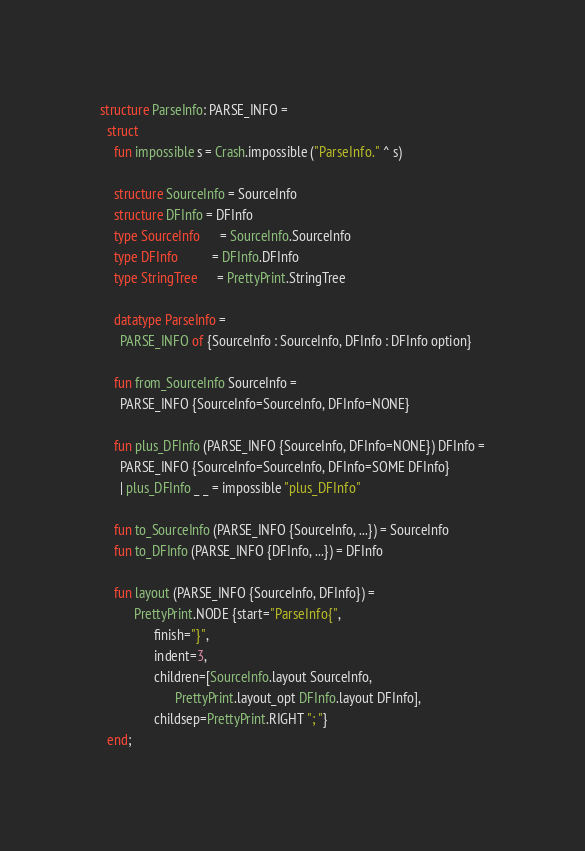<code> <loc_0><loc_0><loc_500><loc_500><_SML_>structure ParseInfo: PARSE_INFO =
  struct
    fun impossible s = Crash.impossible ("ParseInfo." ^ s)

    structure SourceInfo = SourceInfo
    structure DFInfo = DFInfo
    type SourceInfo      = SourceInfo.SourceInfo
    type DFInfo          = DFInfo.DFInfo
    type StringTree      = PrettyPrint.StringTree

    datatype ParseInfo =
      PARSE_INFO of {SourceInfo : SourceInfo, DFInfo : DFInfo option}

    fun from_SourceInfo SourceInfo =
	  PARSE_INFO {SourceInfo=SourceInfo, DFInfo=NONE}

    fun plus_DFInfo (PARSE_INFO {SourceInfo, DFInfo=NONE}) DFInfo =
	  PARSE_INFO {SourceInfo=SourceInfo, DFInfo=SOME DFInfo}
      | plus_DFInfo _ _ = impossible "plus_DFInfo"

    fun to_SourceInfo (PARSE_INFO {SourceInfo, ...}) = SourceInfo
    fun to_DFInfo (PARSE_INFO {DFInfo, ...}) = DFInfo

    fun layout (PARSE_INFO {SourceInfo, DFInfo}) =
          PrettyPrint.NODE {start="ParseInfo{",
			    finish="}",
			    indent=3,
			    children=[SourceInfo.layout SourceInfo,
				      PrettyPrint.layout_opt DFInfo.layout DFInfo],
			    childsep=PrettyPrint.RIGHT "; "}
  end;
</code> 